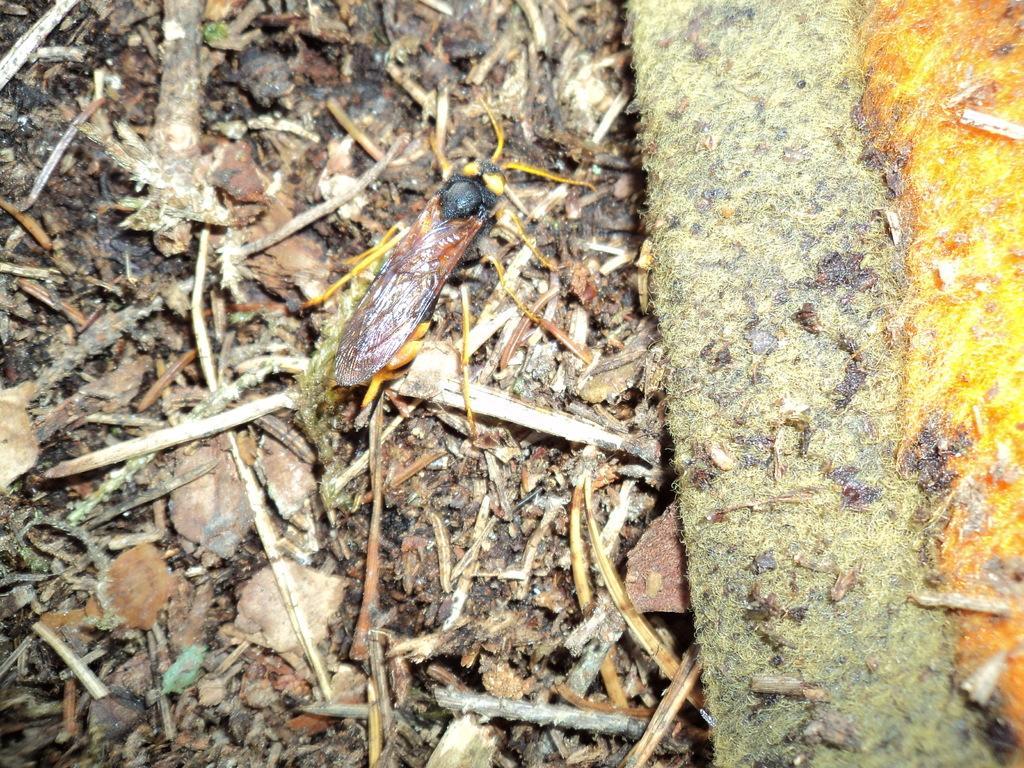Describe this image in one or two sentences. In this image I can see insect in black and brown color on the ground. I can also see few dried leaves and sticks. 